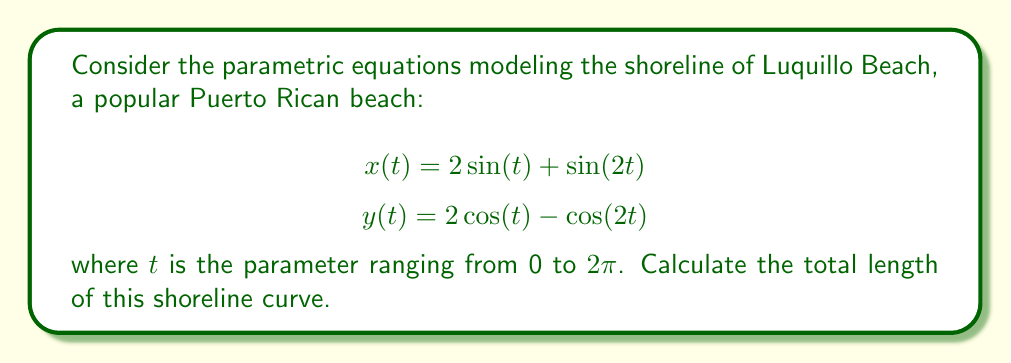Can you solve this math problem? To find the length of the curve, we'll use the arc length formula for parametric equations:

$$L = \int_{a}^{b} \sqrt{\left(\frac{dx}{dt}\right)^2 + \left(\frac{dy}{dt}\right)^2} dt$$

Step 1: Find $\frac{dx}{dt}$ and $\frac{dy}{dt}$
$$\frac{dx}{dt} = 2\cos(t) + 2\cos(2t)$$
$$\frac{dy}{dt} = -2\sin(t) + 2\sin(2t)$$

Step 2: Substitute into the arc length formula
$$L = \int_{0}^{2\pi} \sqrt{(2\cos(t) + 2\cos(2t))^2 + (-2\sin(t) + 2\sin(2t))^2} dt$$

Step 3: Simplify the expression under the square root
$$(2\cos(t) + 2\cos(2t))^2 + (-2\sin(t) + 2\sin(2t))^2$$
$$= 4\cos^2(t) + 8\cos(t)\cos(2t) + 4\cos^2(2t) + 4\sin^2(t) + 8\sin(t)\sin(2t) + 4\sin^2(2t)$$
$$= 4(\cos^2(t) + \sin^2(t)) + 4(\cos^2(2t) + \sin^2(2t)) + 8(\cos(t)\cos(2t) + \sin(t)\sin(2t))$$
$$= 4 + 4 + 8\cos(t-2t) = 8 + 8\cos(t)$$

Step 4: Simplify the integral
$$L = \int_{0}^{2\pi} \sqrt{8 + 8\cos(t)} dt = 4\int_{0}^{2\pi} \sqrt{2 + 2\cos(t)} dt$$

Step 5: Use the identity $\cos(t) = 1 - 2\sin^2(\frac{t}{2})$
$$L = 4\int_{0}^{2\pi} \sqrt{4 - 4\sin^2(\frac{t}{2})} dt = 8\int_{0}^{2\pi} \sqrt{1 - \sin^2(\frac{t}{2})} dt$$

Step 6: Recognize this as an elliptic integral and use the known result
$$\int_{0}^{2\pi} \sqrt{1 - \sin^2(\frac{t}{2})} dt = 4E(1/2)$$

where $E(k)$ is the complete elliptic integral of the second kind.

Step 7: Final result
$$L = 8 \cdot 4E(1/2) = 32E(1/2)$$
Answer: $32E(1/2)$ 